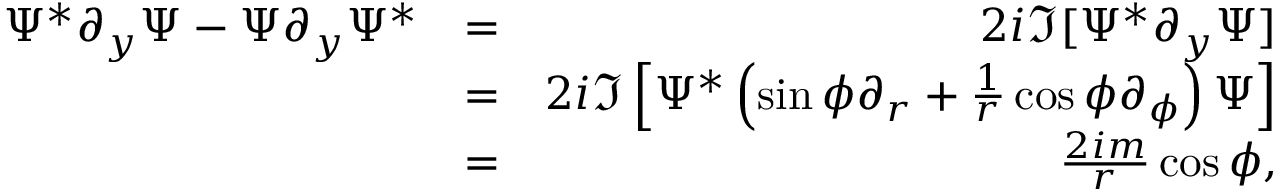Convert formula to latex. <formula><loc_0><loc_0><loc_500><loc_500>\begin{array} { r l r } { \Psi ^ { * } \partial _ { y } \Psi - \Psi \partial _ { y } \Psi ^ { * } } & { = } & { 2 i \Im [ \Psi ^ { * } \partial _ { y } \Psi ] } \\ & { = } & { 2 i \Im \left [ \Psi ^ { * } \left ( \sin \phi \partial _ { r } + \frac { 1 } { r } \cos \phi \partial _ { \phi } \right ) \Psi \right ] } \\ & { = } & { \frac { 2 i m } { r } \cos \phi , } \end{array}</formula> 